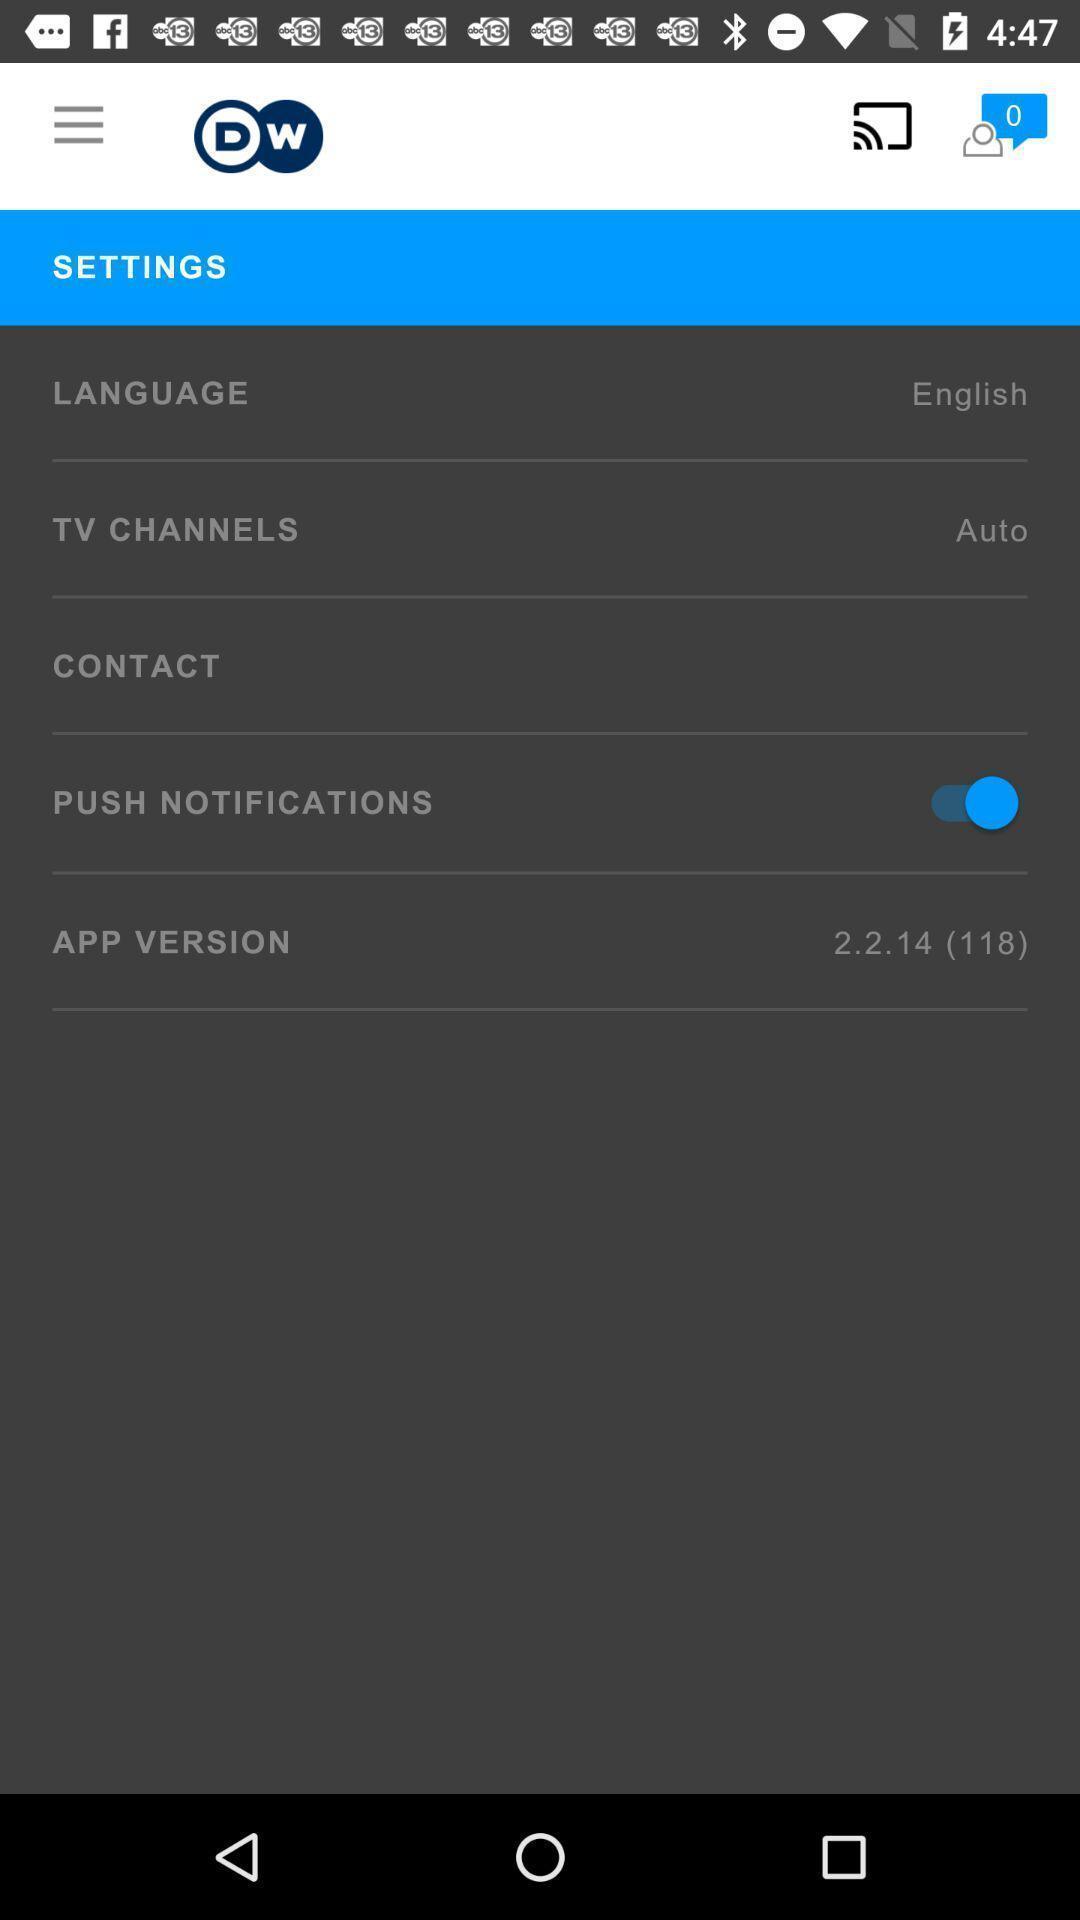Describe the visual elements of this screenshot. Settings page with various options to enable or disable. 